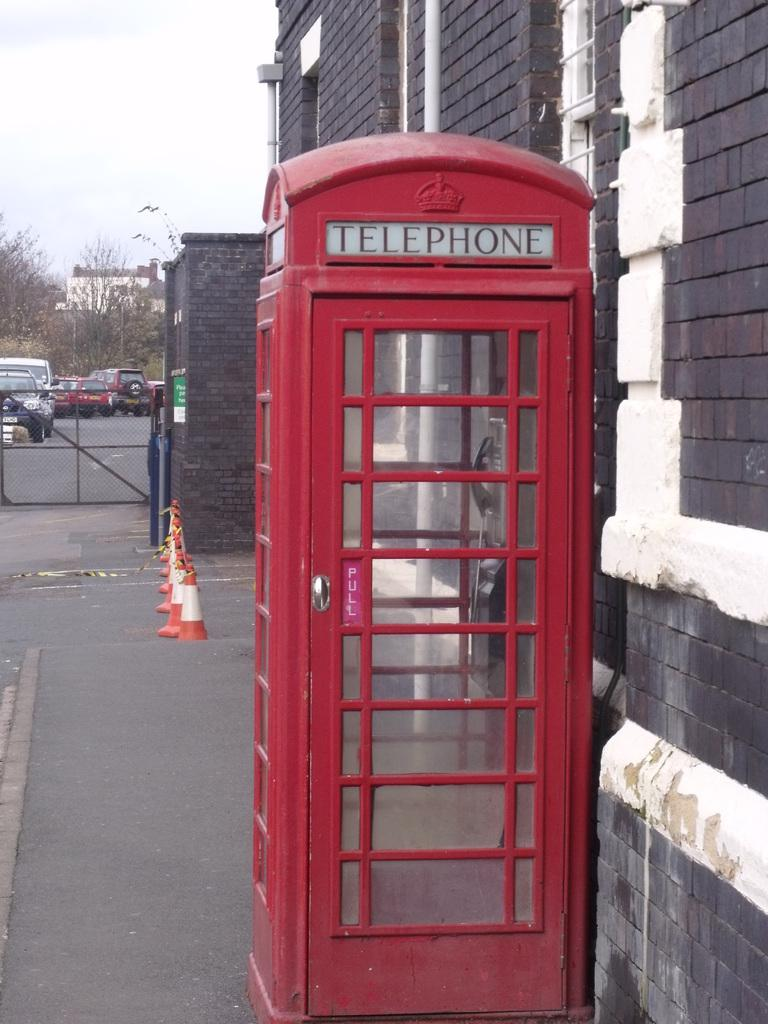<image>
Relay a brief, clear account of the picture shown. A red phone booth has a small purple sign by the handle that says Pull. 